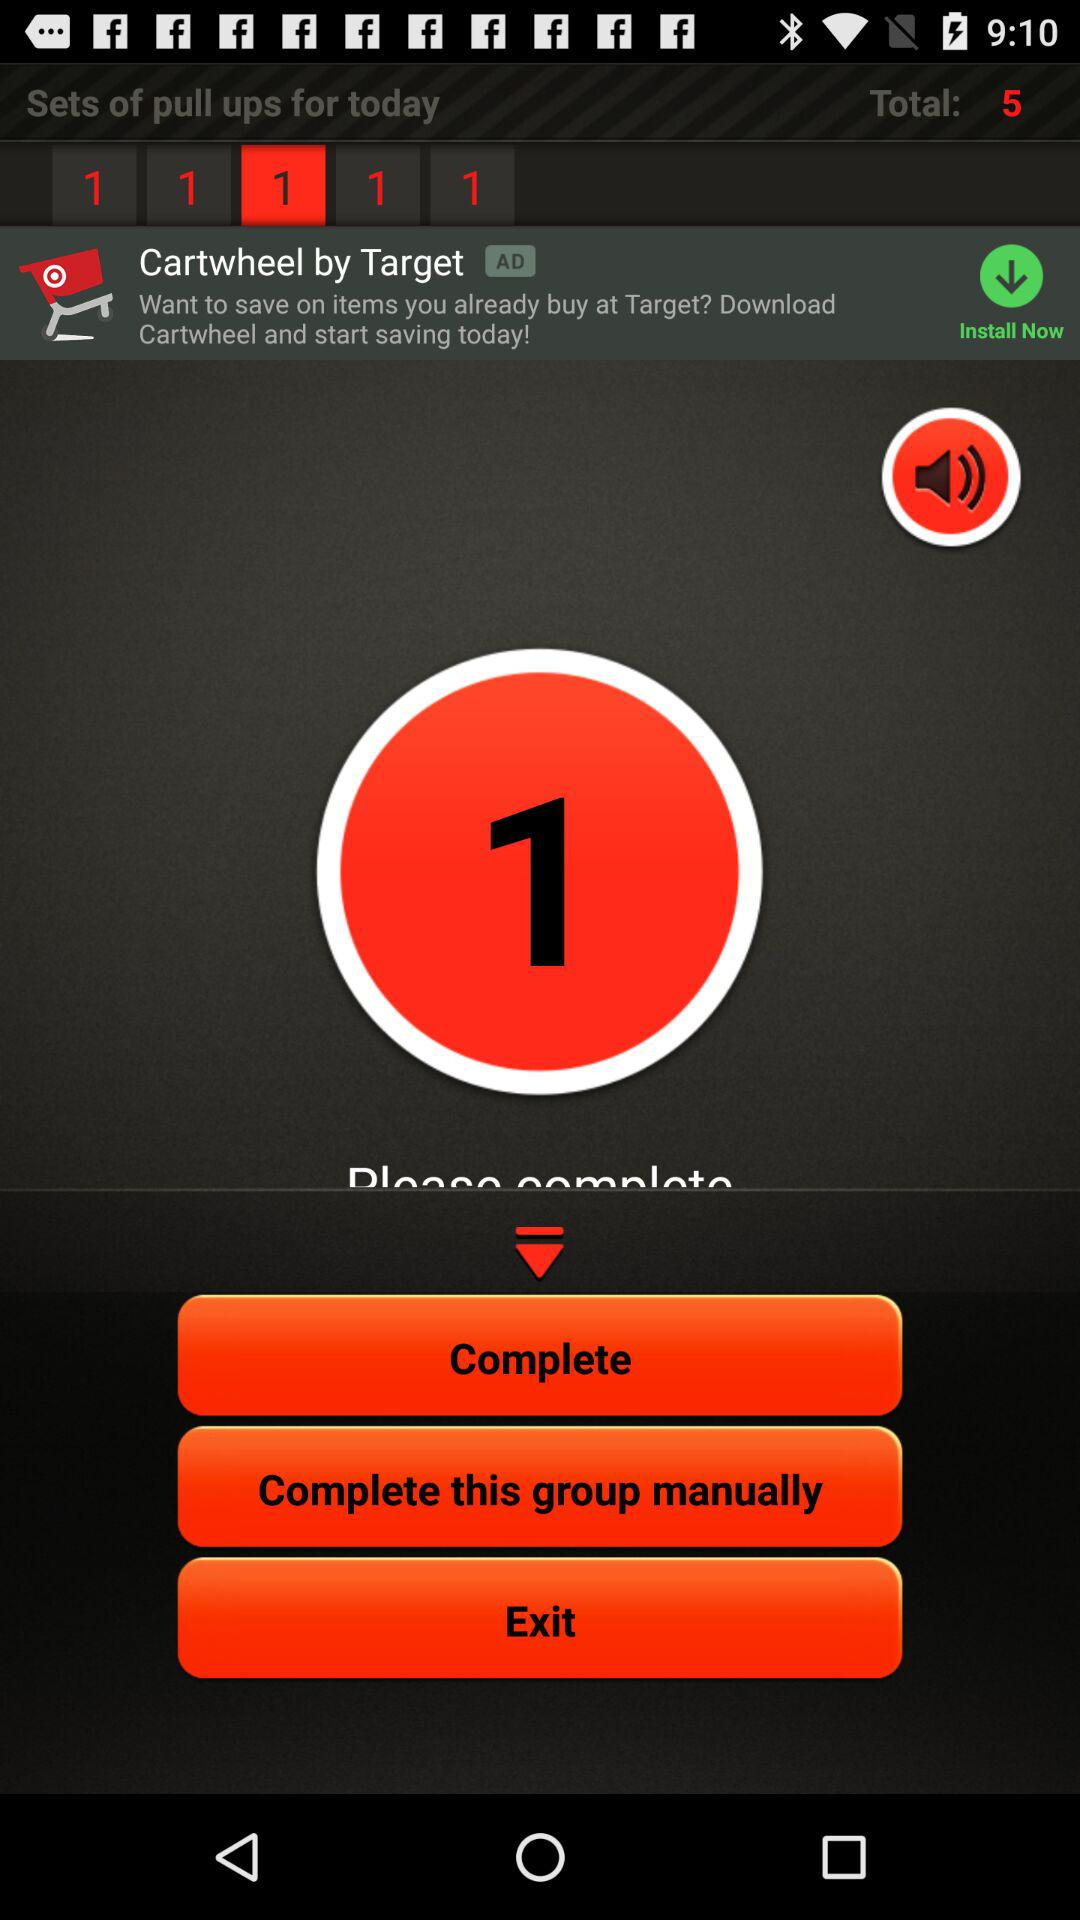What is the total count? The total count is 5. 